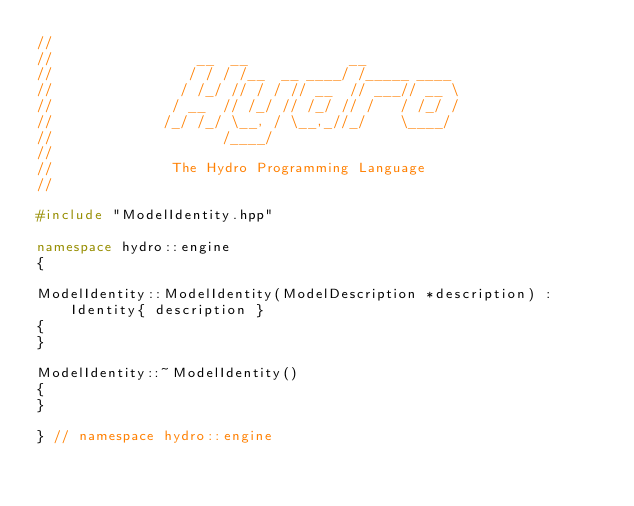<code> <loc_0><loc_0><loc_500><loc_500><_C++_>//
//                 __  __            __           
//                / / / /__  __ ____/ /_____ ____ 
//               / /_/ // / / // __  // ___// __ \
//              / __  // /_/ // /_/ // /   / /_/ /
//             /_/ /_/ \__, / \__,_//_/    \____/ 
//                    /____/                      
//
//              The Hydro Programming Language
//

#include "ModelIdentity.hpp"

namespace hydro::engine
{

ModelIdentity::ModelIdentity(ModelDescription *description) : Identity{ description }
{
}

ModelIdentity::~ModelIdentity()
{
}

} // namespace hydro::engine
</code> 